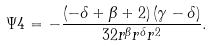Convert formula to latex. <formula><loc_0><loc_0><loc_500><loc_500>\Psi 4 = - \frac { \left ( - \delta + \beta + 2 \right ) \left ( \gamma - \delta \right ) } { 3 2 { r } ^ { \beta } { r } ^ { \delta } { r } ^ { 2 } } .</formula> 